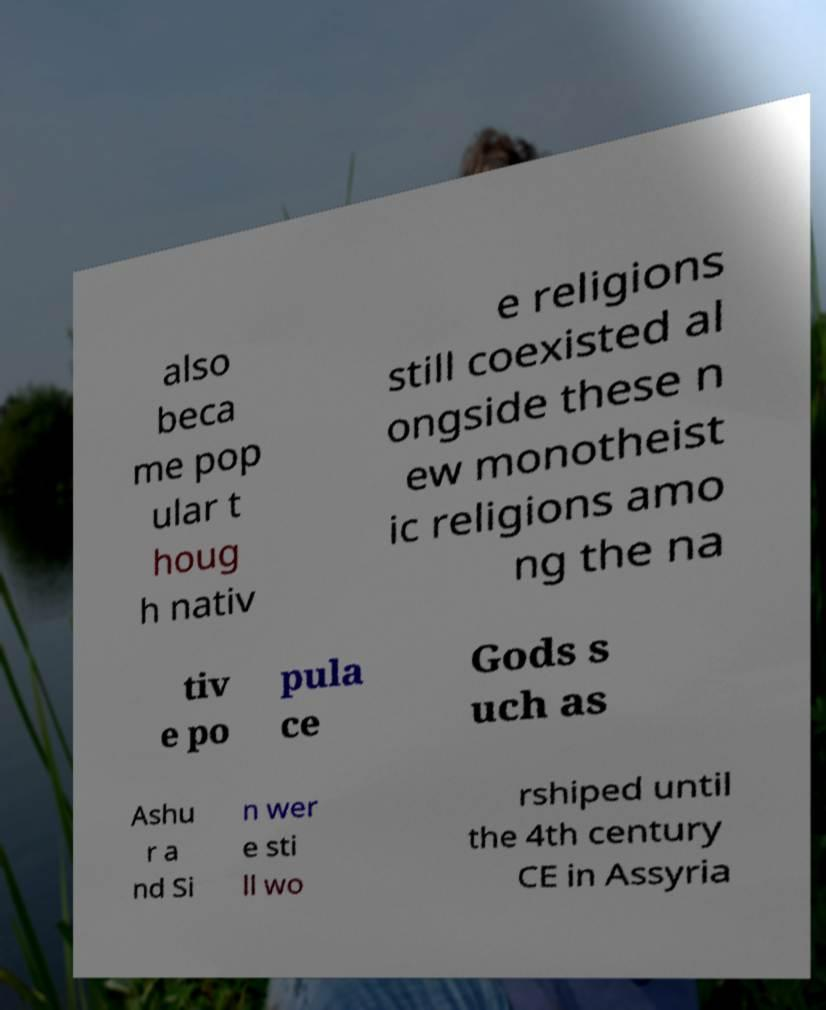For documentation purposes, I need the text within this image transcribed. Could you provide that? also beca me pop ular t houg h nativ e religions still coexisted al ongside these n ew monotheist ic religions amo ng the na tiv e po pula ce Gods s uch as Ashu r a nd Si n wer e sti ll wo rshiped until the 4th century CE in Assyria 